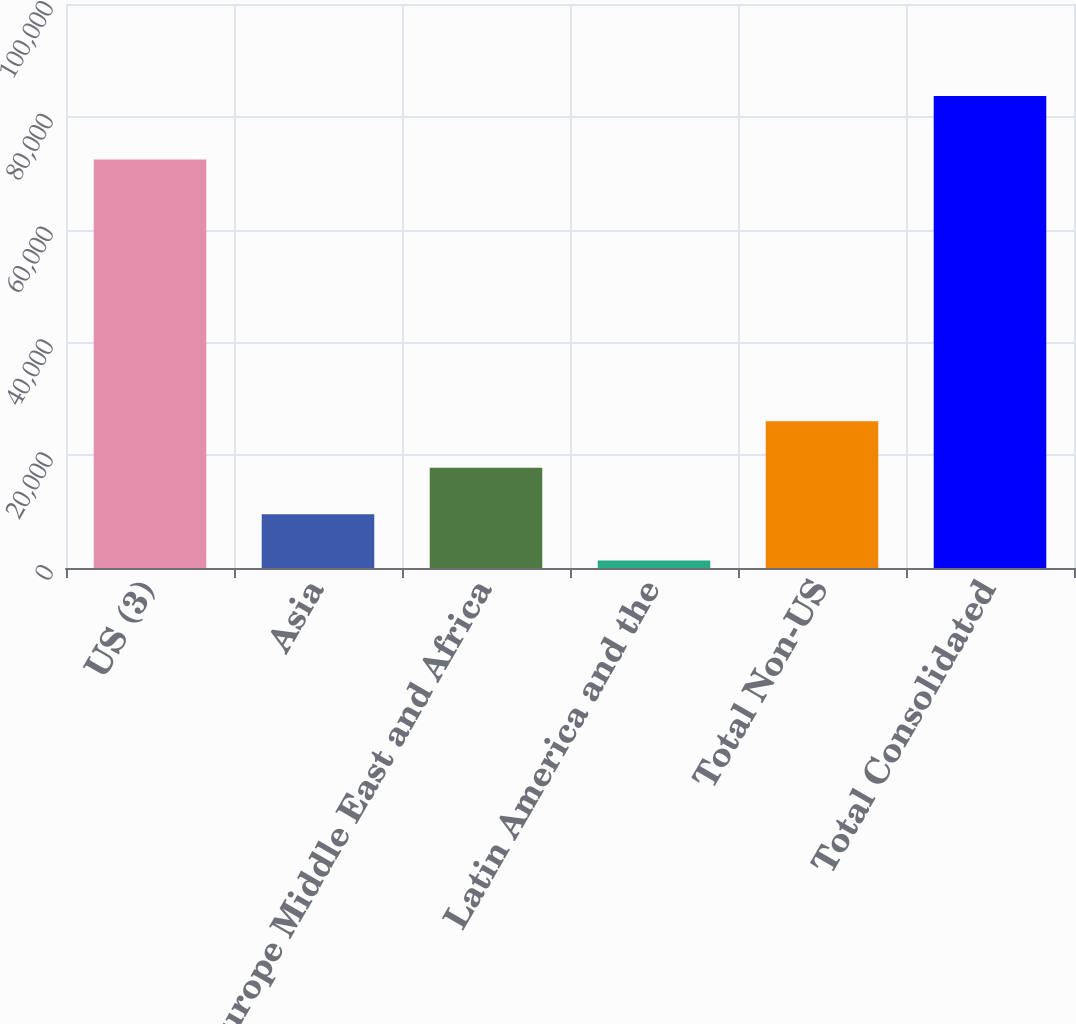Convert chart. <chart><loc_0><loc_0><loc_500><loc_500><bar_chart><fcel>US (3)<fcel>Asia<fcel>Europe Middle East and Africa<fcel>Latin America and the<fcel>Total Non-US<fcel>Total Consolidated<nl><fcel>72418<fcel>9549.1<fcel>17788.2<fcel>1310<fcel>26027.3<fcel>83701<nl></chart> 